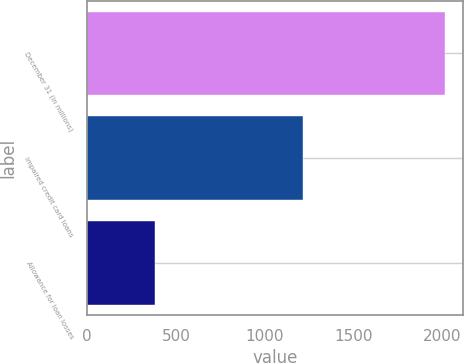Convert chart to OTSL. <chart><loc_0><loc_0><loc_500><loc_500><bar_chart><fcel>December 31 (in millions)<fcel>Impaired credit card loans<fcel>Allowance for loan losses<nl><fcel>2017<fcel>1215<fcel>383<nl></chart> 